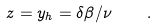<formula> <loc_0><loc_0><loc_500><loc_500>z = y _ { h } = \delta \beta / \nu \quad .</formula> 